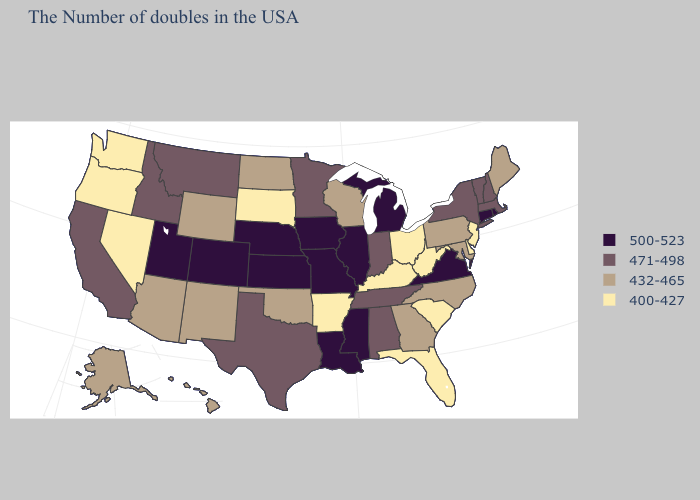What is the highest value in states that border Idaho?
Write a very short answer. 500-523. Does Connecticut have a higher value than Iowa?
Be succinct. No. Name the states that have a value in the range 400-427?
Give a very brief answer. New Jersey, Delaware, South Carolina, West Virginia, Ohio, Florida, Kentucky, Arkansas, South Dakota, Nevada, Washington, Oregon. Name the states that have a value in the range 500-523?
Concise answer only. Rhode Island, Connecticut, Virginia, Michigan, Illinois, Mississippi, Louisiana, Missouri, Iowa, Kansas, Nebraska, Colorado, Utah. Among the states that border Texas , which have the highest value?
Quick response, please. Louisiana. Does the first symbol in the legend represent the smallest category?
Quick response, please. No. What is the lowest value in the USA?
Keep it brief. 400-427. Which states have the lowest value in the USA?
Short answer required. New Jersey, Delaware, South Carolina, West Virginia, Ohio, Florida, Kentucky, Arkansas, South Dakota, Nevada, Washington, Oregon. Name the states that have a value in the range 400-427?
Keep it brief. New Jersey, Delaware, South Carolina, West Virginia, Ohio, Florida, Kentucky, Arkansas, South Dakota, Nevada, Washington, Oregon. Name the states that have a value in the range 432-465?
Answer briefly. Maine, Maryland, Pennsylvania, North Carolina, Georgia, Wisconsin, Oklahoma, North Dakota, Wyoming, New Mexico, Arizona, Alaska, Hawaii. What is the lowest value in the USA?
Concise answer only. 400-427. What is the highest value in states that border California?
Keep it brief. 432-465. What is the highest value in the USA?
Concise answer only. 500-523. Name the states that have a value in the range 471-498?
Short answer required. Massachusetts, New Hampshire, Vermont, New York, Indiana, Alabama, Tennessee, Minnesota, Texas, Montana, Idaho, California. Among the states that border Michigan , which have the lowest value?
Concise answer only. Ohio. 